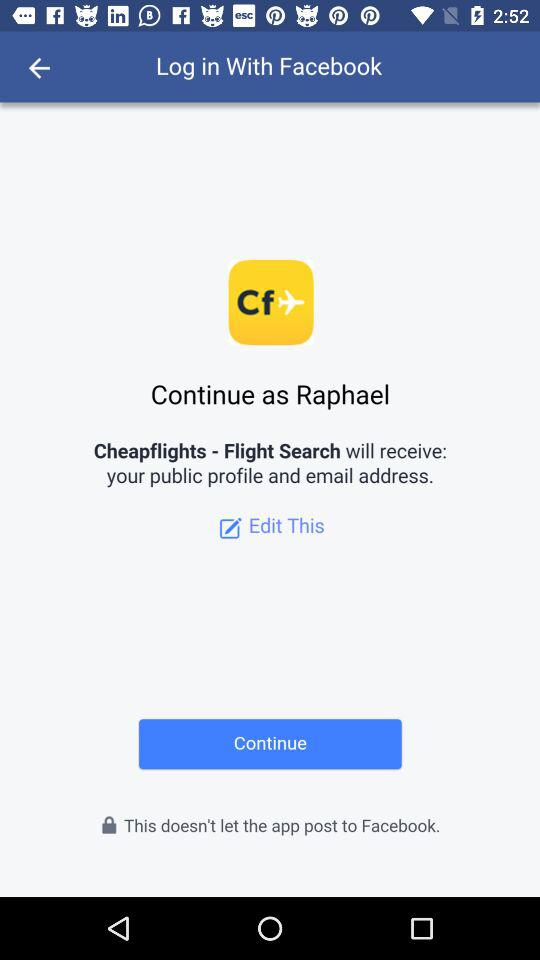Through what application can we log in? The application is "Facebook". 